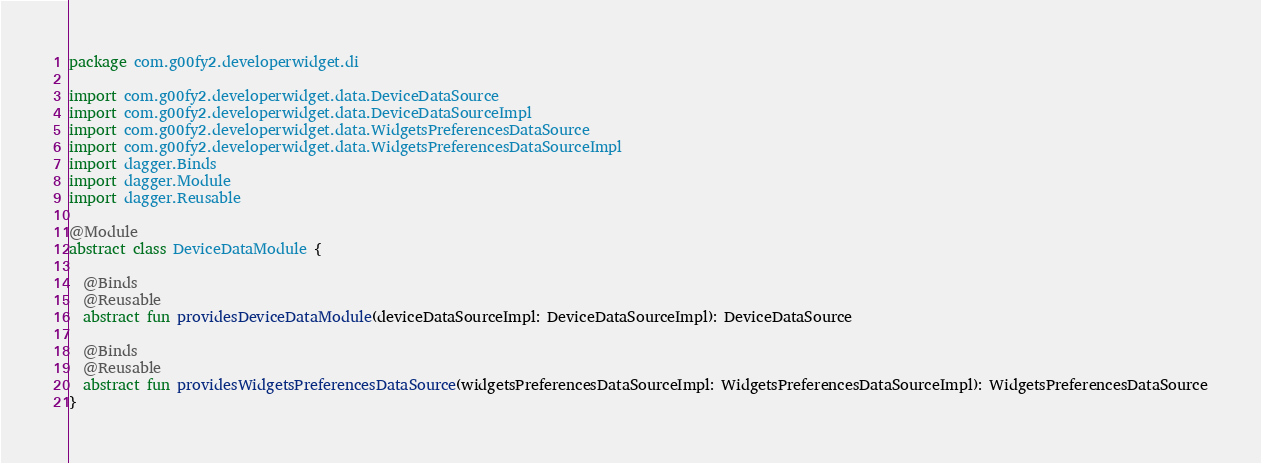<code> <loc_0><loc_0><loc_500><loc_500><_Kotlin_>package com.g00fy2.developerwidget.di

import com.g00fy2.developerwidget.data.DeviceDataSource
import com.g00fy2.developerwidget.data.DeviceDataSourceImpl
import com.g00fy2.developerwidget.data.WidgetsPreferencesDataSource
import com.g00fy2.developerwidget.data.WidgetsPreferencesDataSourceImpl
import dagger.Binds
import dagger.Module
import dagger.Reusable

@Module
abstract class DeviceDataModule {

  @Binds
  @Reusable
  abstract fun providesDeviceDataModule(deviceDataSourceImpl: DeviceDataSourceImpl): DeviceDataSource

  @Binds
  @Reusable
  abstract fun providesWidgetsPreferencesDataSource(widgetsPreferencesDataSourceImpl: WidgetsPreferencesDataSourceImpl): WidgetsPreferencesDataSource
}</code> 